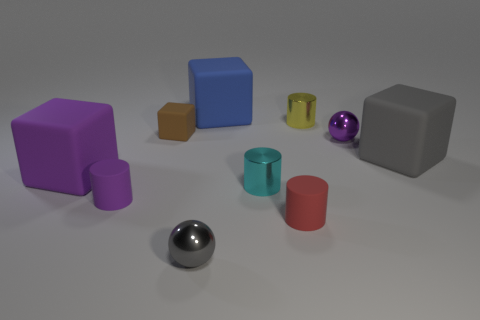Subtract all gray blocks. How many blocks are left? 3 Subtract 2 blocks. How many blocks are left? 2 Subtract all cyan cylinders. How many cylinders are left? 3 Subtract all green blocks. Subtract all green balls. How many blocks are left? 4 Subtract all balls. How many objects are left? 8 Add 8 tiny purple objects. How many tiny purple objects are left? 10 Add 5 tiny brown objects. How many tiny brown objects exist? 6 Subtract 1 blue cubes. How many objects are left? 9 Subtract all small objects. Subtract all brown metal cylinders. How many objects are left? 3 